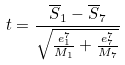<formula> <loc_0><loc_0><loc_500><loc_500>t = \frac { \overline { S } _ { 1 } - \overline { S } _ { 7 } } { \sqrt { \frac { e _ { 1 } ^ { 7 } } { M _ { 1 } } + \frac { e _ { 7 } ^ { 7 } } { M _ { 7 } } } }</formula> 